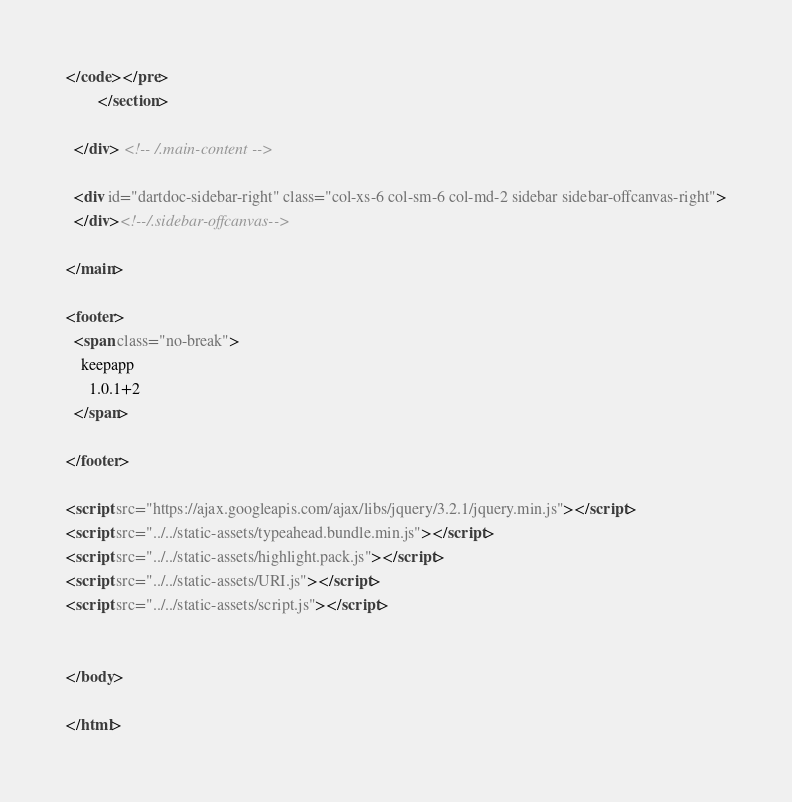<code> <loc_0><loc_0><loc_500><loc_500><_HTML_>
</code></pre>
        </section>

  </div> <!-- /.main-content -->

  <div id="dartdoc-sidebar-right" class="col-xs-6 col-sm-6 col-md-2 sidebar sidebar-offcanvas-right">
  </div><!--/.sidebar-offcanvas-->

</main>

<footer>
  <span class="no-break">
    keepapp
      1.0.1+2
  </span>

</footer>

<script src="https://ajax.googleapis.com/ajax/libs/jquery/3.2.1/jquery.min.js"></script>
<script src="../../static-assets/typeahead.bundle.min.js"></script>
<script src="../../static-assets/highlight.pack.js"></script>
<script src="../../static-assets/URI.js"></script>
<script src="../../static-assets/script.js"></script>


</body>

</html>
</code> 